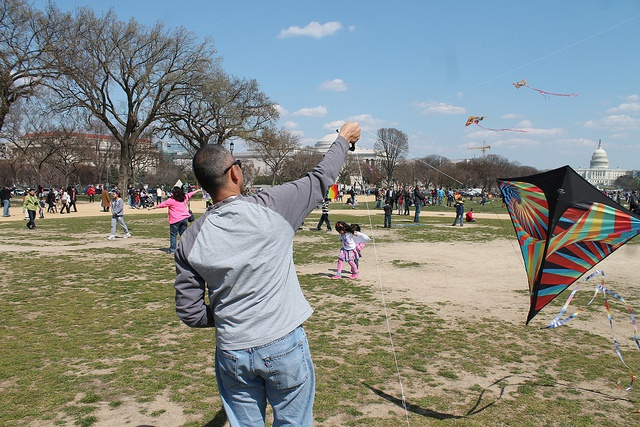Describe the objects in this image and their specific colors. I can see people in gray, darkgray, lightgray, and black tones, kite in gray, black, brown, and maroon tones, people in gray, black, darkgray, and tan tones, people in gray, black, and violet tones, and people in gray, darkgray, and lightgray tones in this image. 